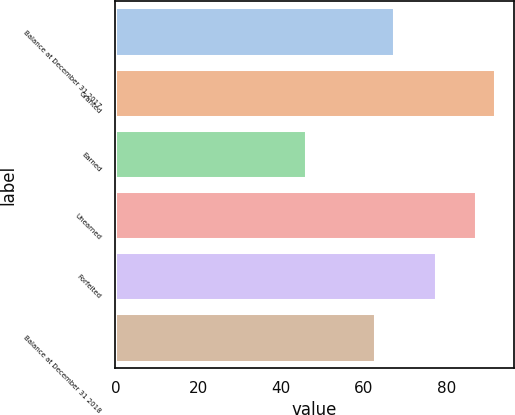Convert chart. <chart><loc_0><loc_0><loc_500><loc_500><bar_chart><fcel>Balance at December 31 2017<fcel>Granted<fcel>Earned<fcel>Unearned<fcel>Forfeited<fcel>Balance at December 31 2018<nl><fcel>67.32<fcel>91.6<fcel>46.08<fcel>87.01<fcel>77.26<fcel>62.77<nl></chart> 